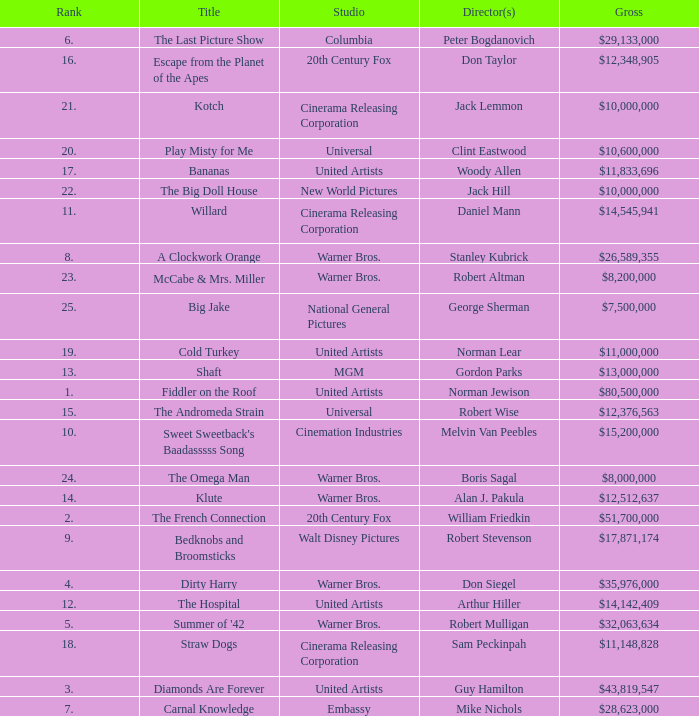What rank is the title with a gross of $26,589,355? 8.0. Can you parse all the data within this table? {'header': ['Rank', 'Title', 'Studio', 'Director(s)', 'Gross'], 'rows': [['6.', 'The Last Picture Show', 'Columbia', 'Peter Bogdanovich', '$29,133,000'], ['16.', 'Escape from the Planet of the Apes', '20th Century Fox', 'Don Taylor', '$12,348,905'], ['21.', 'Kotch', 'Cinerama Releasing Corporation', 'Jack Lemmon', '$10,000,000'], ['20.', 'Play Misty for Me', 'Universal', 'Clint Eastwood', '$10,600,000'], ['17.', 'Bananas', 'United Artists', 'Woody Allen', '$11,833,696'], ['22.', 'The Big Doll House', 'New World Pictures', 'Jack Hill', '$10,000,000'], ['11.', 'Willard', 'Cinerama Releasing Corporation', 'Daniel Mann', '$14,545,941'], ['8.', 'A Clockwork Orange', 'Warner Bros.', 'Stanley Kubrick', '$26,589,355'], ['23.', 'McCabe & Mrs. Miller', 'Warner Bros.', 'Robert Altman', '$8,200,000'], ['25.', 'Big Jake', 'National General Pictures', 'George Sherman', '$7,500,000'], ['19.', 'Cold Turkey', 'United Artists', 'Norman Lear', '$11,000,000'], ['13.', 'Shaft', 'MGM', 'Gordon Parks', '$13,000,000'], ['1.', 'Fiddler on the Roof', 'United Artists', 'Norman Jewison', '$80,500,000'], ['15.', 'The Andromeda Strain', 'Universal', 'Robert Wise', '$12,376,563'], ['10.', "Sweet Sweetback's Baadasssss Song", 'Cinemation Industries', 'Melvin Van Peebles', '$15,200,000'], ['24.', 'The Omega Man', 'Warner Bros.', 'Boris Sagal', '$8,000,000'], ['14.', 'Klute', 'Warner Bros.', 'Alan J. Pakula', '$12,512,637'], ['2.', 'The French Connection', '20th Century Fox', 'William Friedkin', '$51,700,000'], ['9.', 'Bedknobs and Broomsticks', 'Walt Disney Pictures', 'Robert Stevenson', '$17,871,174'], ['4.', 'Dirty Harry', 'Warner Bros.', 'Don Siegel', '$35,976,000'], ['12.', 'The Hospital', 'United Artists', 'Arthur Hiller', '$14,142,409'], ['5.', "Summer of '42", 'Warner Bros.', 'Robert Mulligan', '$32,063,634'], ['18.', 'Straw Dogs', 'Cinerama Releasing Corporation', 'Sam Peckinpah', '$11,148,828'], ['3.', 'Diamonds Are Forever', 'United Artists', 'Guy Hamilton', '$43,819,547'], ['7.', 'Carnal Knowledge', 'Embassy', 'Mike Nichols', '$28,623,000']]} 